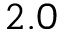Convert formula to latex. <formula><loc_0><loc_0><loc_500><loc_500>2 . 0</formula> 